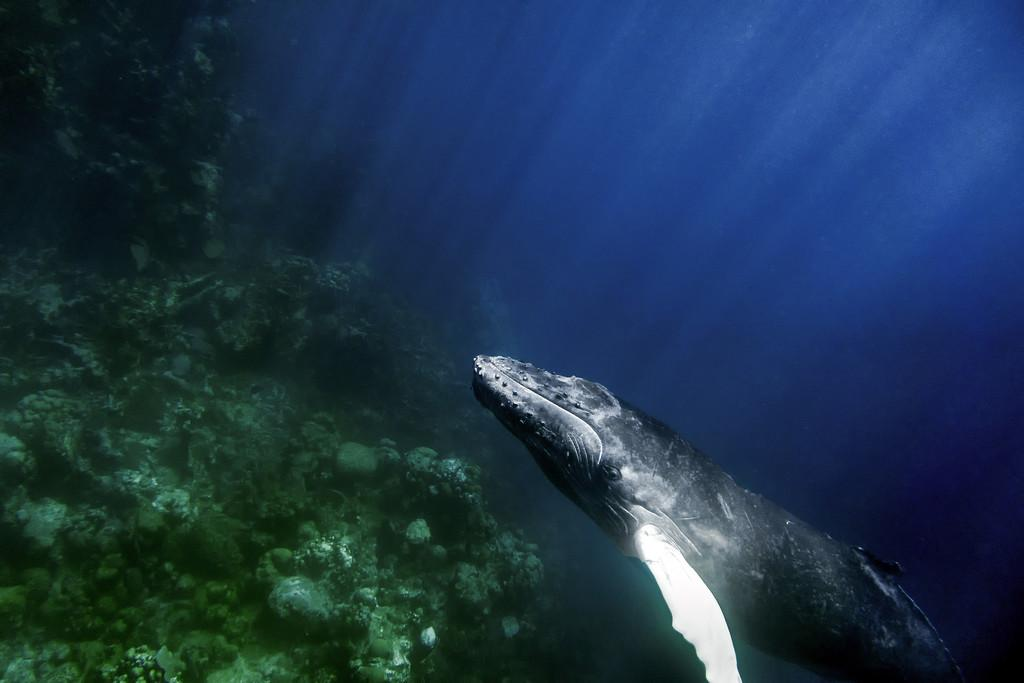What type of environment is shown in the image? The image depicts an underground water environment. What types of marine life can be seen in the image? There are fish in the image. What other features can be observed in the image? There are corals in the image. How many children are playing with pencils in the image? There are no children or pencils present in the image; it depicts an underground water environment with fish and corals. 